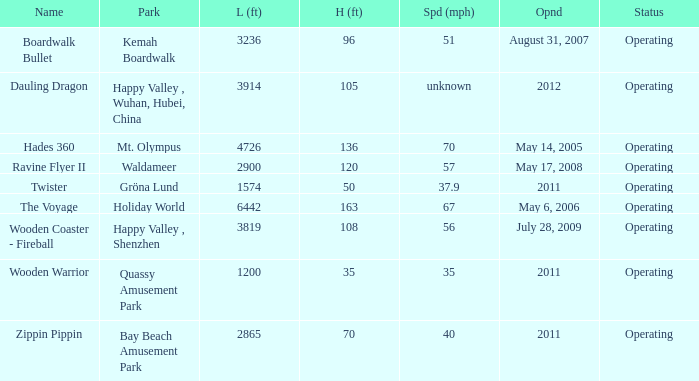How many parks are called mt. olympus 1.0. 